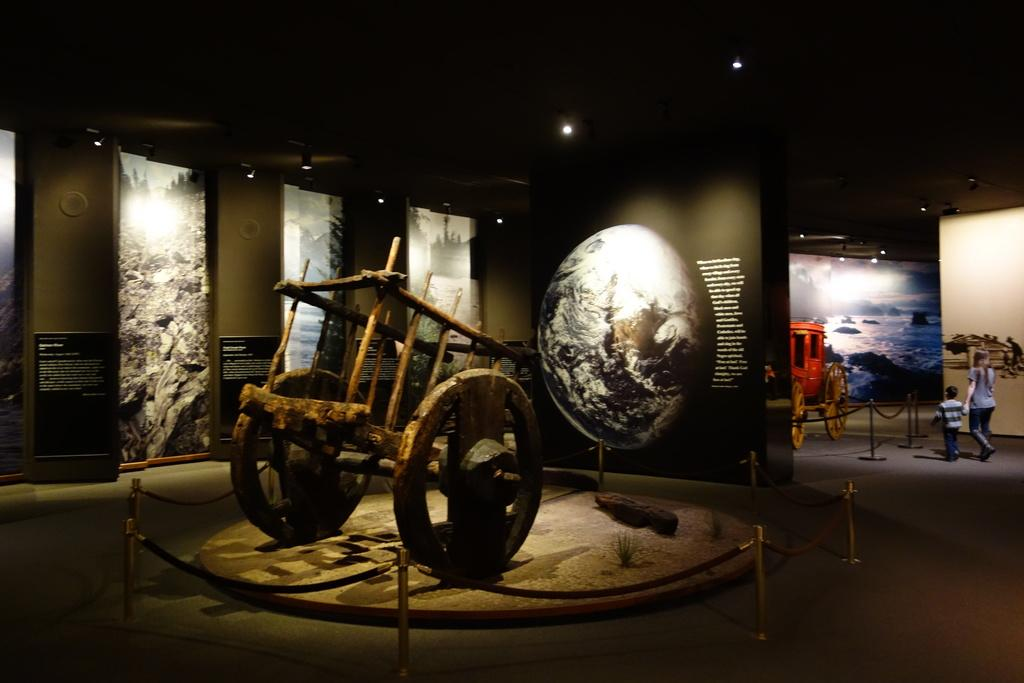What is the main subject of the image? There is a bullock cart in the image. Where is the bullock cart located? The bullock cart is on the floor. In what setting is the image captured? The image is set in a museum. How many people are visible in the image? There are two people on the right side of the image. Can you describe the gender of the people? One of the people is a woman, and the other person is a kid. How much zinc is present in the bullock cart? There is no information about the presence of zinc in the bullock cart or the image. 